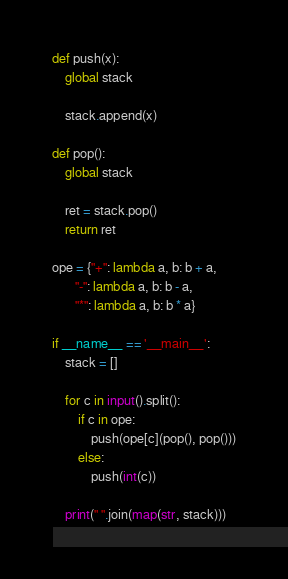<code> <loc_0><loc_0><loc_500><loc_500><_Python_>def push(x):
	global stack

	stack.append(x)

def pop():
	global stack

	ret = stack.pop()
	return ret

ope = {"+": lambda a, b: b + a,
	   "-": lambda a, b: b - a,
	   "*": lambda a, b: b * a}

if __name__ == '__main__':
	stack = []

	for c in input().split():
		if c in ope:
			push(ope[c](pop(), pop()))
		else:
			push(int(c))

	print(" ".join(map(str, stack)))</code> 